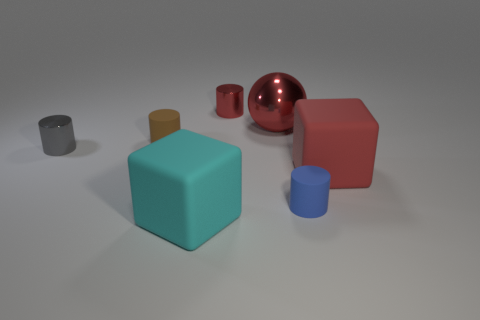Add 1 brown objects. How many objects exist? 8 Subtract all cylinders. How many objects are left? 3 Subtract 0 purple spheres. How many objects are left? 7 Subtract all large red metallic objects. Subtract all large cubes. How many objects are left? 4 Add 5 tiny gray objects. How many tiny gray objects are left? 6 Add 1 big red shiny objects. How many big red shiny objects exist? 2 